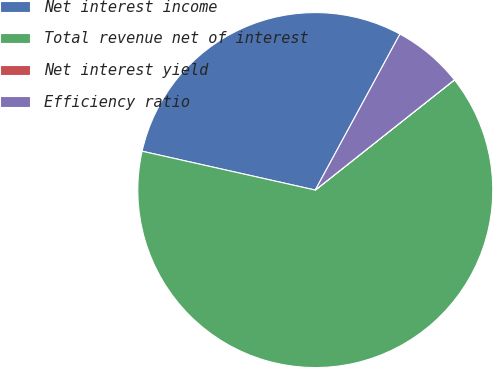Convert chart to OTSL. <chart><loc_0><loc_0><loc_500><loc_500><pie_chart><fcel>Net interest income<fcel>Total revenue net of interest<fcel>Net interest yield<fcel>Efficiency ratio<nl><fcel>29.4%<fcel>64.17%<fcel>0.01%<fcel>6.42%<nl></chart> 